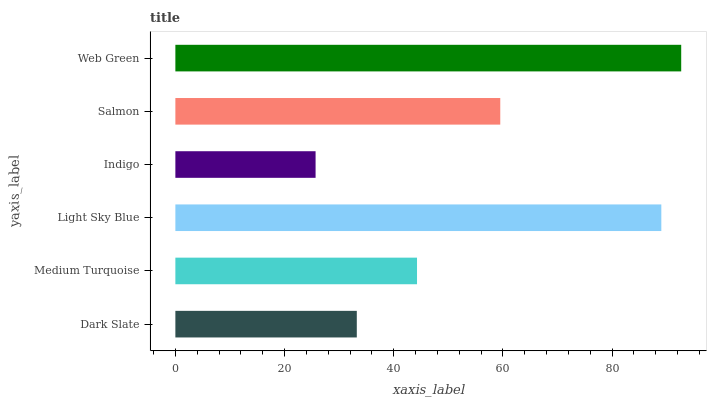Is Indigo the minimum?
Answer yes or no. Yes. Is Web Green the maximum?
Answer yes or no. Yes. Is Medium Turquoise the minimum?
Answer yes or no. No. Is Medium Turquoise the maximum?
Answer yes or no. No. Is Medium Turquoise greater than Dark Slate?
Answer yes or no. Yes. Is Dark Slate less than Medium Turquoise?
Answer yes or no. Yes. Is Dark Slate greater than Medium Turquoise?
Answer yes or no. No. Is Medium Turquoise less than Dark Slate?
Answer yes or no. No. Is Salmon the high median?
Answer yes or no. Yes. Is Medium Turquoise the low median?
Answer yes or no. Yes. Is Indigo the high median?
Answer yes or no. No. Is Web Green the low median?
Answer yes or no. No. 